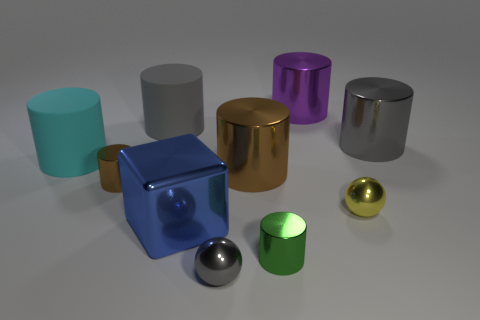Is the shape of the tiny yellow thing the same as the gray metal thing behind the small gray sphere?
Offer a very short reply. No. Is the shape of the gray object in front of the big cyan matte cylinder the same as  the purple object?
Ensure brevity in your answer.  No. How many brown cylinders are both on the left side of the gray matte cylinder and on the right side of the big blue cube?
Your answer should be very brief. 0. What number of other objects are there of the same size as the purple metallic cylinder?
Offer a terse response. 5. Are there an equal number of large cyan rubber cylinders that are on the left side of the cyan thing and yellow rubber cubes?
Keep it short and to the point. Yes. There is a big cylinder on the left side of the large gray matte cylinder; does it have the same color as the small metallic sphere that is on the right side of the small gray thing?
Ensure brevity in your answer.  No. There is a gray object that is both right of the large metallic block and on the left side of the yellow thing; what is it made of?
Ensure brevity in your answer.  Metal. The metal cube is what color?
Offer a terse response. Blue. What number of other things are the same shape as the large cyan matte object?
Offer a very short reply. 6. Are there the same number of small balls that are right of the tiny gray sphere and large purple metallic cylinders in front of the tiny brown metallic cylinder?
Your answer should be compact. No. 